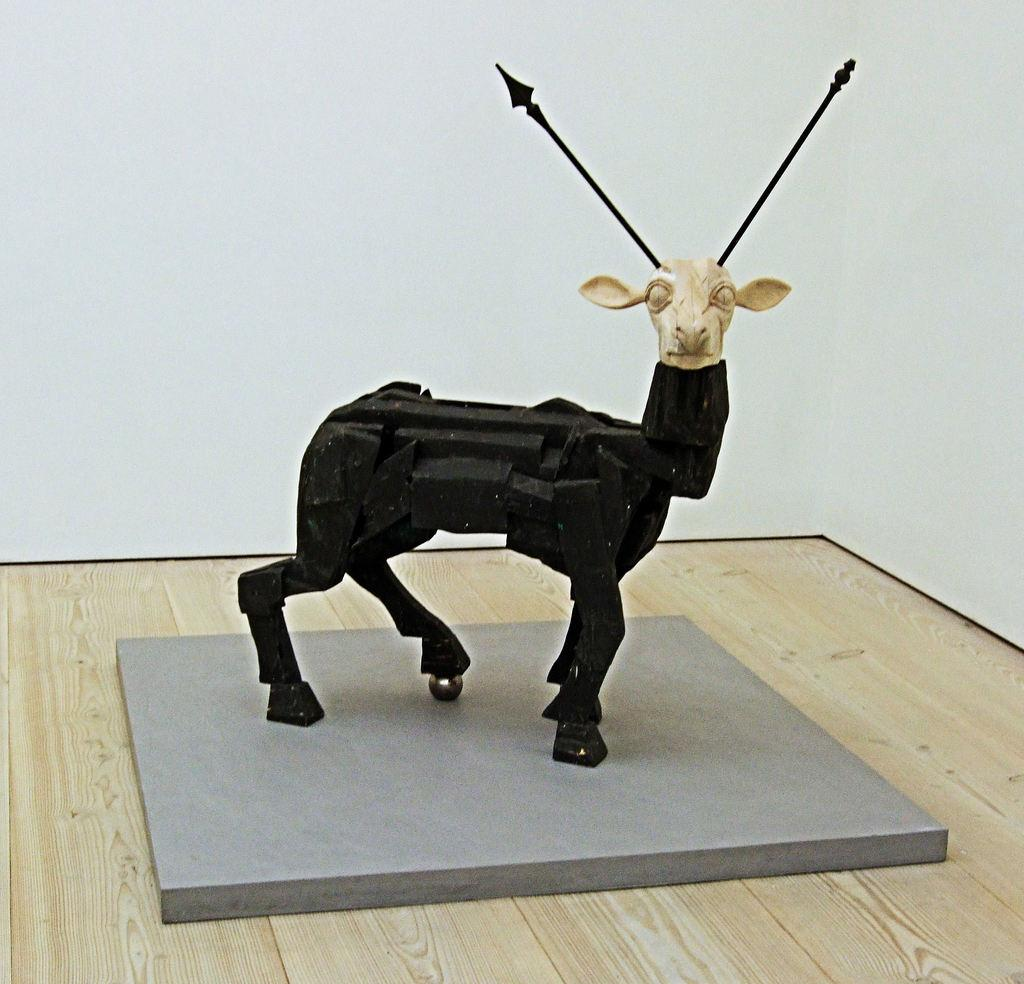What is the main subject in the foreground of the picture? There is an animal sculpture in the foreground of the picture. What type of animal does the sculpture resemble? The sculpture resembles a deer. What can be seen in the background of the image? There is a white wall in the background of the image. How does the boy say good-bye to the deer sculpture in the image? There is no boy present in the image, and therefore no interaction between a boy and the deer sculpture can be observed. 